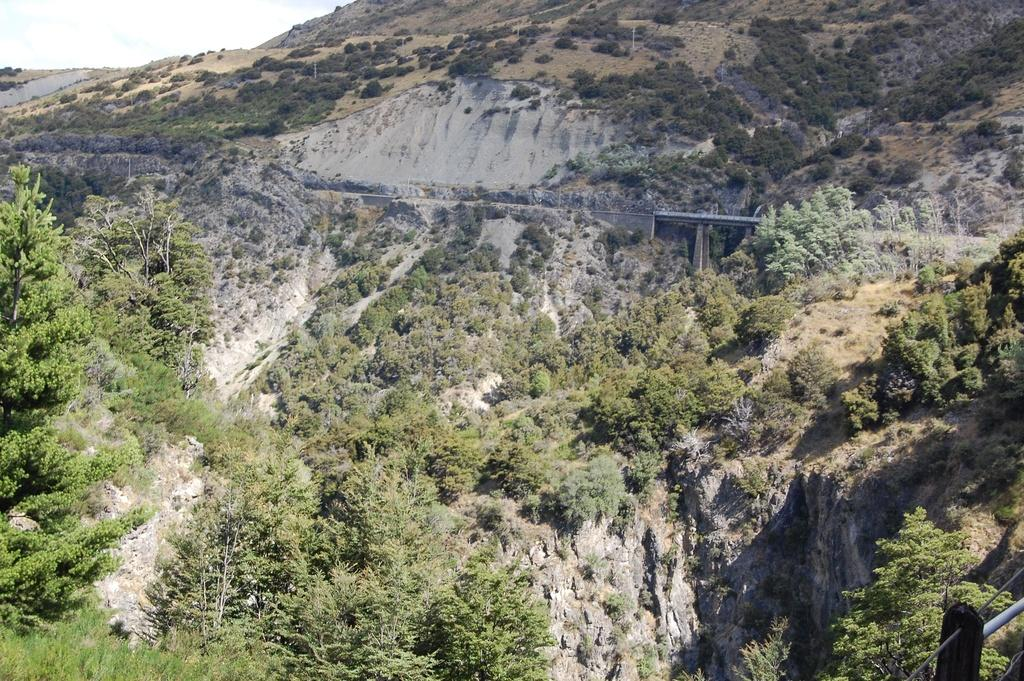What type of plant is present in the image? The image contains Mexican pinyon. Can you describe the natural elements in the image? There are trees in the image. Where is the boundary located in the image? The boundary is in the bottom right side of the image. What type of stone can be seen in the image? There is no stone present in the image; it features Mexican pinyon and trees. How does the waste affect the image? There is no waste present in the image, so its impact cannot be determined. 